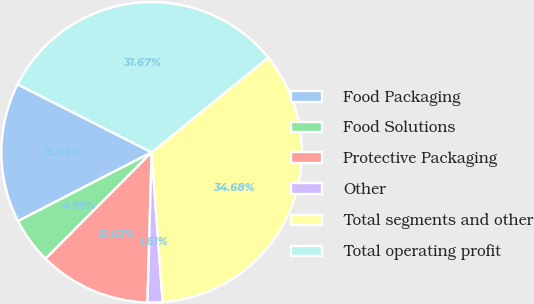Convert chart to OTSL. <chart><loc_0><loc_0><loc_500><loc_500><pie_chart><fcel>Food Packaging<fcel>Food Solutions<fcel>Protective Packaging<fcel>Other<fcel>Total segments and other<fcel>Total operating profit<nl><fcel>15.04%<fcel>4.96%<fcel>12.03%<fcel>1.61%<fcel>34.68%<fcel>31.67%<nl></chart> 